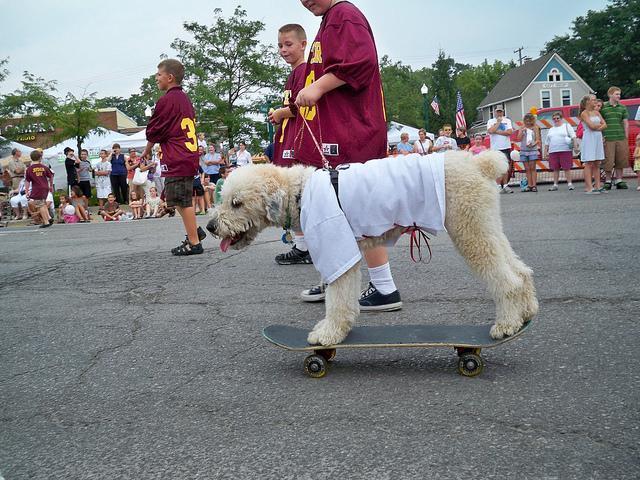How many people are in the picture?
Give a very brief answer. 5. How many chairs are visible?
Give a very brief answer. 0. 